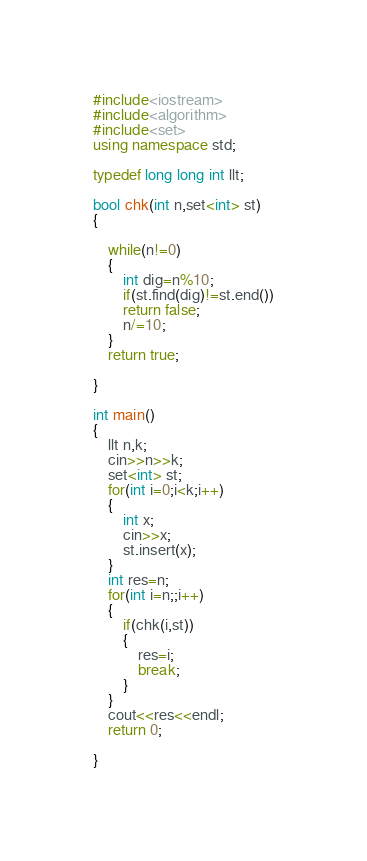Convert code to text. <code><loc_0><loc_0><loc_500><loc_500><_C++_>#include<iostream>
#include<algorithm>
#include<set>
using namespace std;

typedef long long int llt;

bool chk(int n,set<int> st)
{
	
	while(n!=0)
	{
		int dig=n%10;
		if(st.find(dig)!=st.end())
		return false;
		n/=10;
	}
	return true;

}

int main()
{
	llt n,k;
	cin>>n>>k;
	set<int> st;
	for(int i=0;i<k;i++)
	{
		int x;
		cin>>x;
		st.insert(x);
	}
	int res=n;
	for(int i=n;;i++)
	{
		if(chk(i,st))
		{
			res=i;
			break;
		}
	}
	cout<<res<<endl;
	return 0;
	
}</code> 